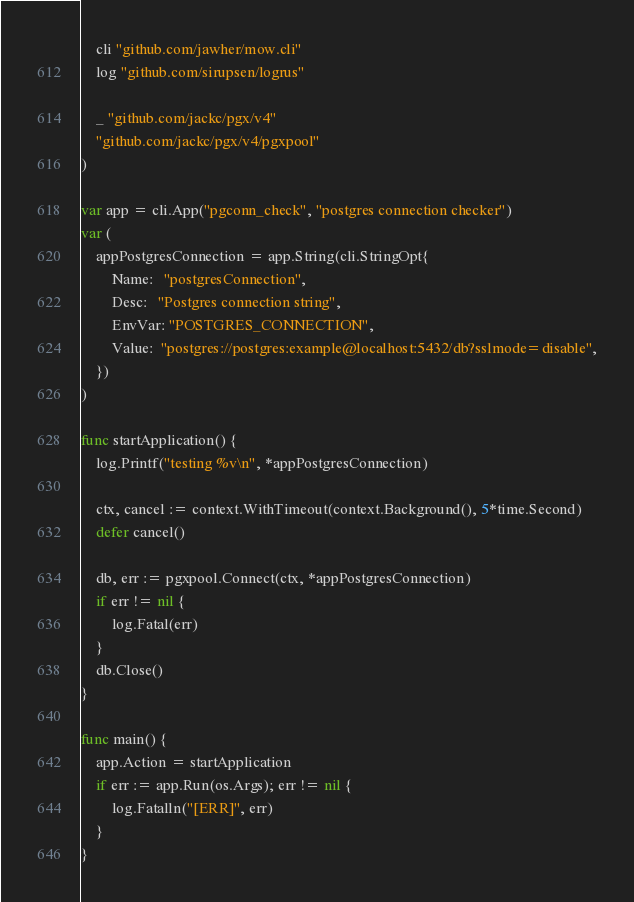<code> <loc_0><loc_0><loc_500><loc_500><_Go_>
	cli "github.com/jawher/mow.cli"
	log "github.com/sirupsen/logrus"

	_ "github.com/jackc/pgx/v4"
	"github.com/jackc/pgx/v4/pgxpool"
)

var app = cli.App("pgconn_check", "postgres connection checker")
var (
	appPostgresConnection = app.String(cli.StringOpt{
		Name:   "postgresConnection",
		Desc:   "Postgres connection string",
		EnvVar: "POSTGRES_CONNECTION",
		Value:  "postgres://postgres:example@localhost:5432/db?sslmode=disable",
	})
)

func startApplication() {
	log.Printf("testing %v\n", *appPostgresConnection)

	ctx, cancel := context.WithTimeout(context.Background(), 5*time.Second)
	defer cancel()

	db, err := pgxpool.Connect(ctx, *appPostgresConnection)
	if err != nil {
		log.Fatal(err)
	}
	db.Close()
}

func main() {
	app.Action = startApplication
	if err := app.Run(os.Args); err != nil {
		log.Fatalln("[ERR]", err)
	}
}
</code> 